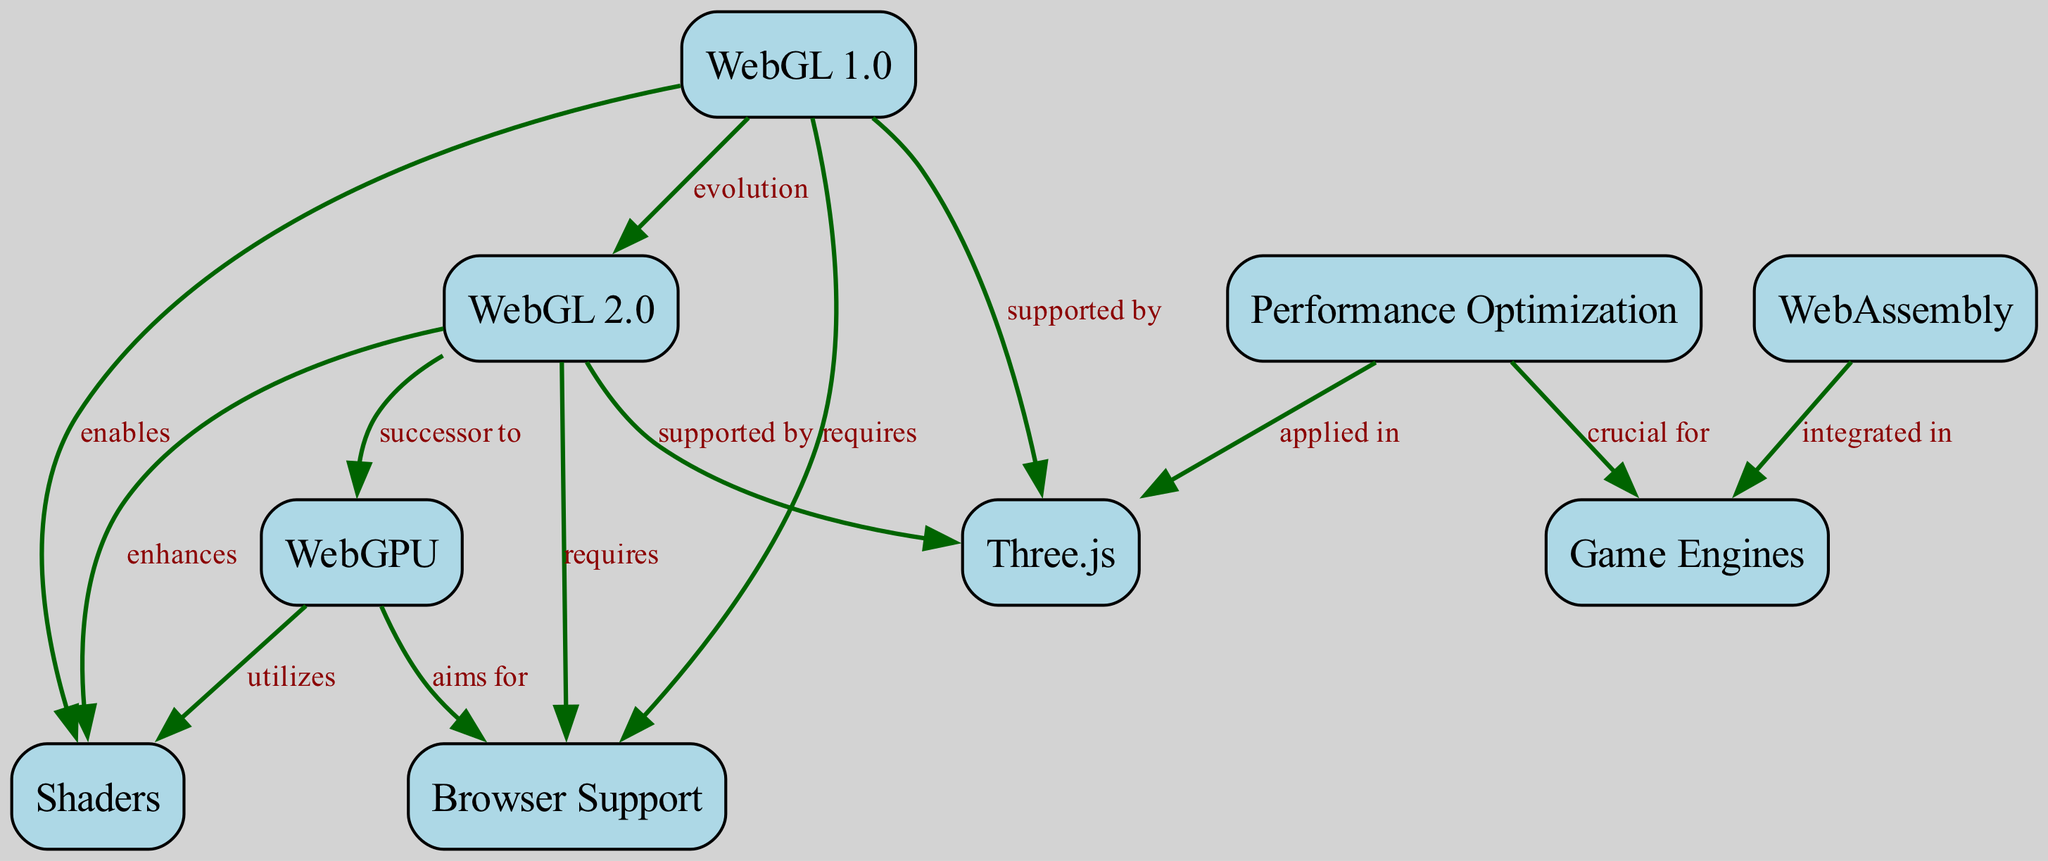What is the release year of WebGL 1.0? The diagram indicates that WebGL 1.0 was released in 2011, which is specified in the node details.
Answer: 2011 What does WebGL 2.0 enhance? According to the diagram, WebGL 2.0 enhances shaders, as indicated by the relationship link connecting these two nodes.
Answer: Shaders How many nodes are present in the diagram? By counting the nodes listed in the diagram data, there are a total of 9 nodes that represent different technologies and concepts related to WebGL.
Answer: 9 Which technology is a successor to WebGL 2.0? The diagram states that WebGPU is the successor to WebGL 2.0, which is represented by a direct relationship link between these two nodes.
Answer: WebGPU What is integrated into Game Engines according to the diagram? The relationship indicates that WebAssembly is integrated into Game Engines, which is clarified in the link mapping this connection.
Answer: WebAssembly What does Performance Optimization apply to? The diagram shows that Performance Optimization is applied in Three.js, as marked by the directed link between the two nodes, making this connection clear.
Answer: Three.js Which standard requires browser support? Both WebGL 1.0 and WebGL 2.0 require browser support, as indicated by the separate relationships showing the requirement for these versions. Specifically, this is stated directly in the linked connections.
Answer: WebGL 1.0 and WebGL 2.0 What is the main purpose of shaders in the context of WebGL? Shaders control the shading of objects and are essential for creating advanced gaming graphics, as explained in the node detailing shaders and the relationships connected to it.
Answer: Control shading of objects What future access to GPUs does WebGPU aim for? The diagram indicates that WebGPU aims for direct and low-level access to GPU resources, as specified in the detailed information associated with this node.
Answer: Low-level access to GPU 